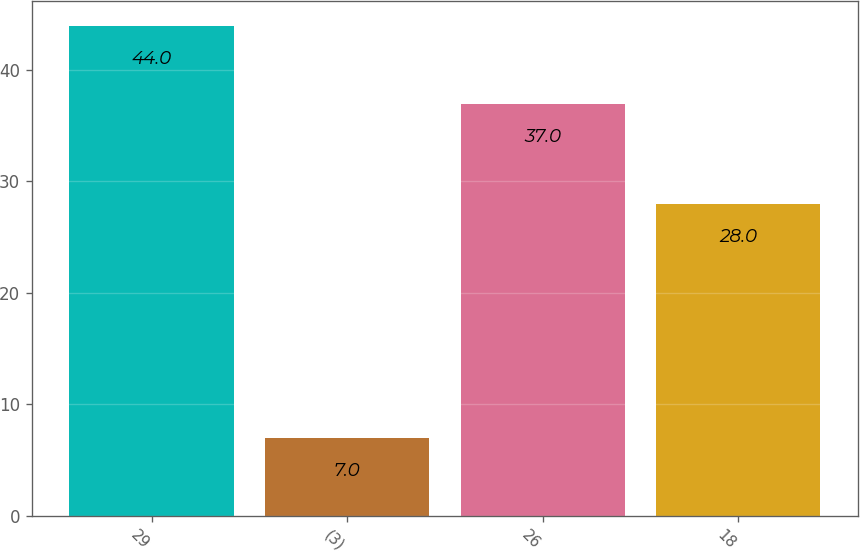<chart> <loc_0><loc_0><loc_500><loc_500><bar_chart><fcel>29<fcel>(3)<fcel>26<fcel>18<nl><fcel>44<fcel>7<fcel>37<fcel>28<nl></chart> 